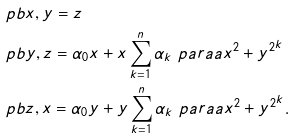Convert formula to latex. <formula><loc_0><loc_0><loc_500><loc_500>& \ p b { x , y } = z \\ & \ p b { y , z } = \alpha _ { 0 } x + x \sum _ { k = 1 } ^ { n } \alpha _ { k } \ p a r a a { x ^ { 2 } + y ^ { 2 } } ^ { k } \\ & \ p b { z , x } = \alpha _ { 0 } y + y \sum _ { k = 1 } ^ { n } \alpha _ { k } \ p a r a a { x ^ { 2 } + y ^ { 2 } } ^ { k } .</formula> 